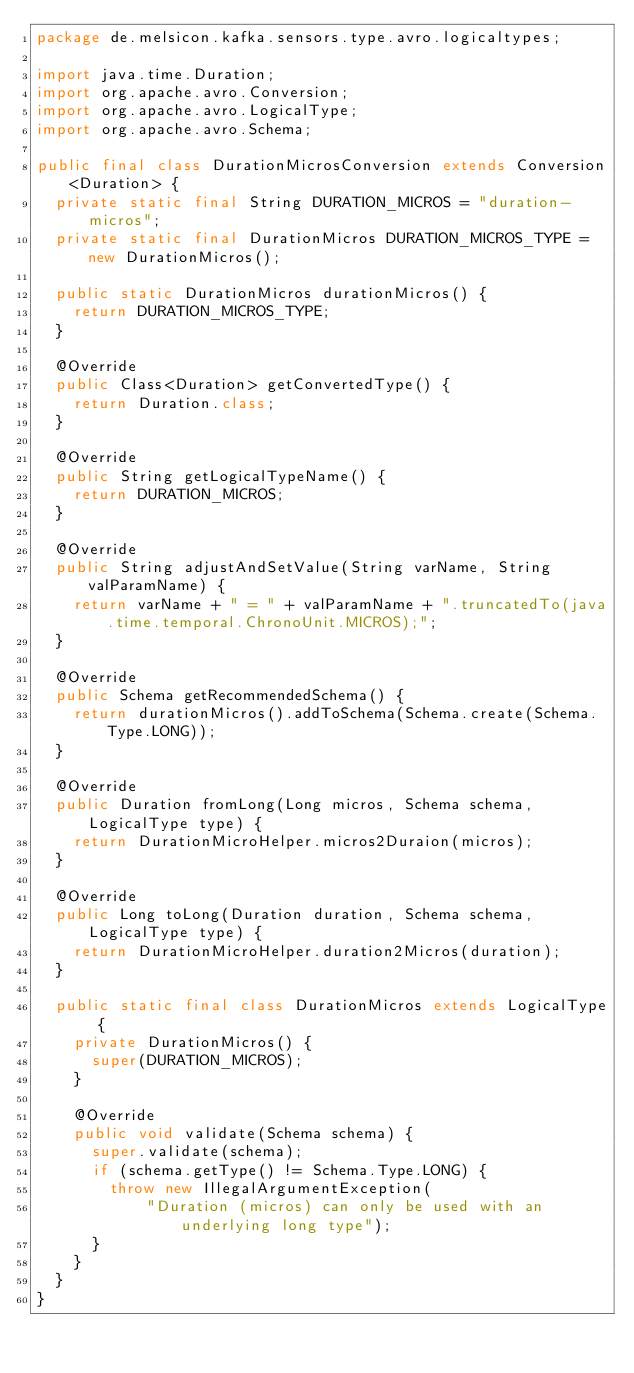Convert code to text. <code><loc_0><loc_0><loc_500><loc_500><_Java_>package de.melsicon.kafka.sensors.type.avro.logicaltypes;

import java.time.Duration;
import org.apache.avro.Conversion;
import org.apache.avro.LogicalType;
import org.apache.avro.Schema;

public final class DurationMicrosConversion extends Conversion<Duration> {
  private static final String DURATION_MICROS = "duration-micros";
  private static final DurationMicros DURATION_MICROS_TYPE = new DurationMicros();

  public static DurationMicros durationMicros() {
    return DURATION_MICROS_TYPE;
  }

  @Override
  public Class<Duration> getConvertedType() {
    return Duration.class;
  }

  @Override
  public String getLogicalTypeName() {
    return DURATION_MICROS;
  }

  @Override
  public String adjustAndSetValue(String varName, String valParamName) {
    return varName + " = " + valParamName + ".truncatedTo(java.time.temporal.ChronoUnit.MICROS);";
  }

  @Override
  public Schema getRecommendedSchema() {
    return durationMicros().addToSchema(Schema.create(Schema.Type.LONG));
  }

  @Override
  public Duration fromLong(Long micros, Schema schema, LogicalType type) {
    return DurationMicroHelper.micros2Duraion(micros);
  }

  @Override
  public Long toLong(Duration duration, Schema schema, LogicalType type) {
    return DurationMicroHelper.duration2Micros(duration);
  }

  public static final class DurationMicros extends LogicalType {
    private DurationMicros() {
      super(DURATION_MICROS);
    }

    @Override
    public void validate(Schema schema) {
      super.validate(schema);
      if (schema.getType() != Schema.Type.LONG) {
        throw new IllegalArgumentException(
            "Duration (micros) can only be used with an underlying long type");
      }
    }
  }
}
</code> 